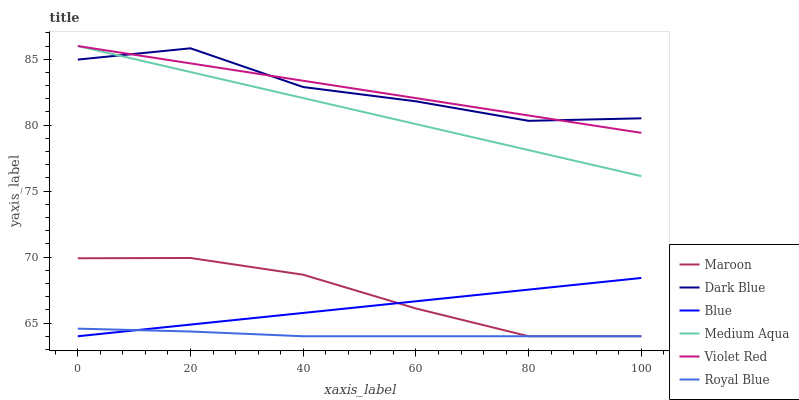Does Royal Blue have the minimum area under the curve?
Answer yes or no. Yes. Does Dark Blue have the maximum area under the curve?
Answer yes or no. Yes. Does Violet Red have the minimum area under the curve?
Answer yes or no. No. Does Violet Red have the maximum area under the curve?
Answer yes or no. No. Is Violet Red the smoothest?
Answer yes or no. Yes. Is Dark Blue the roughest?
Answer yes or no. Yes. Is Royal Blue the smoothest?
Answer yes or no. No. Is Royal Blue the roughest?
Answer yes or no. No. Does Blue have the lowest value?
Answer yes or no. Yes. Does Violet Red have the lowest value?
Answer yes or no. No. Does Medium Aqua have the highest value?
Answer yes or no. Yes. Does Royal Blue have the highest value?
Answer yes or no. No. Is Blue less than Dark Blue?
Answer yes or no. Yes. Is Medium Aqua greater than Maroon?
Answer yes or no. Yes. Does Violet Red intersect Medium Aqua?
Answer yes or no. Yes. Is Violet Red less than Medium Aqua?
Answer yes or no. No. Is Violet Red greater than Medium Aqua?
Answer yes or no. No. Does Blue intersect Dark Blue?
Answer yes or no. No. 